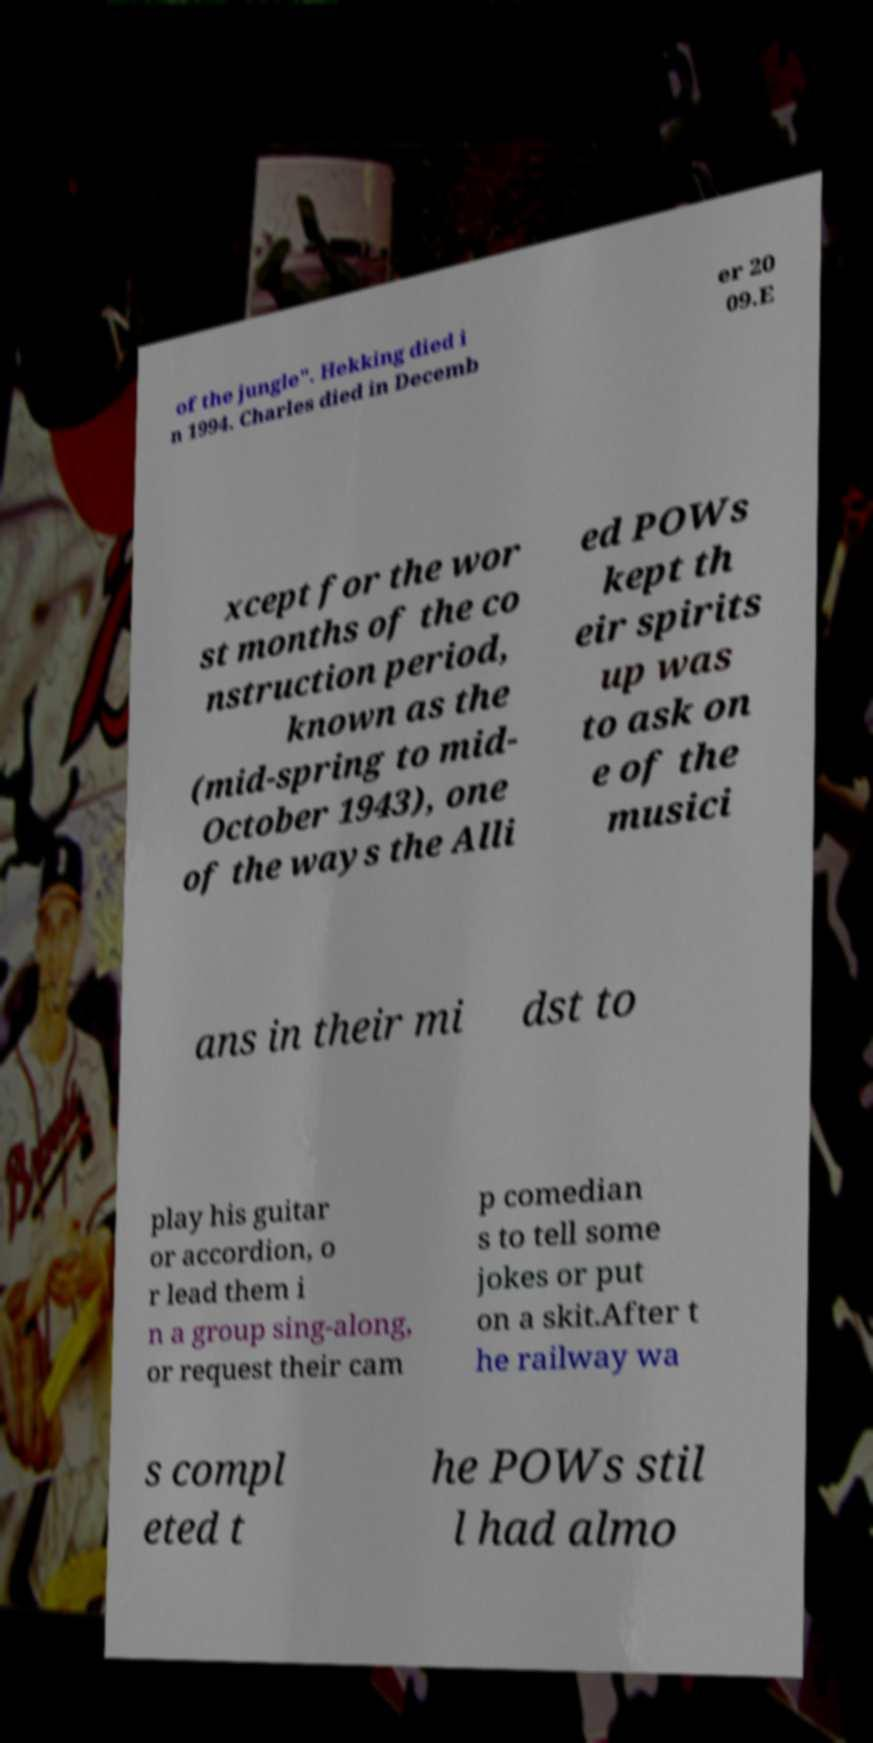Can you read and provide the text displayed in the image?This photo seems to have some interesting text. Can you extract and type it out for me? of the jungle". Hekking died i n 1994. Charles died in Decemb er 20 09.E xcept for the wor st months of the co nstruction period, known as the (mid-spring to mid- October 1943), one of the ways the Alli ed POWs kept th eir spirits up was to ask on e of the musici ans in their mi dst to play his guitar or accordion, o r lead them i n a group sing-along, or request their cam p comedian s to tell some jokes or put on a skit.After t he railway wa s compl eted t he POWs stil l had almo 